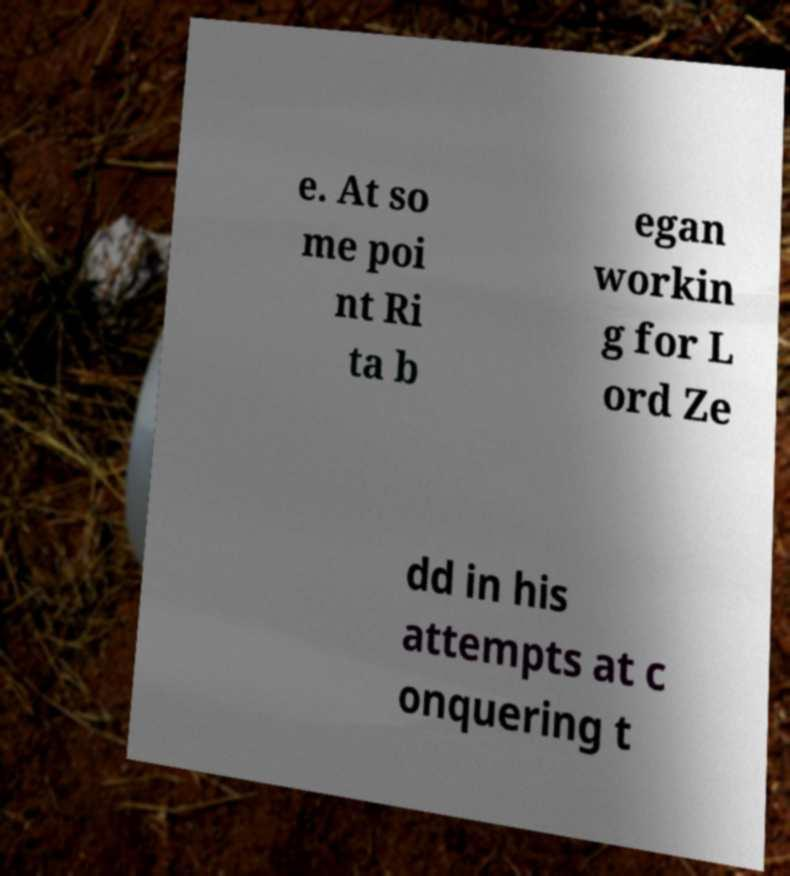Can you accurately transcribe the text from the provided image for me? e. At so me poi nt Ri ta b egan workin g for L ord Ze dd in his attempts at c onquering t 